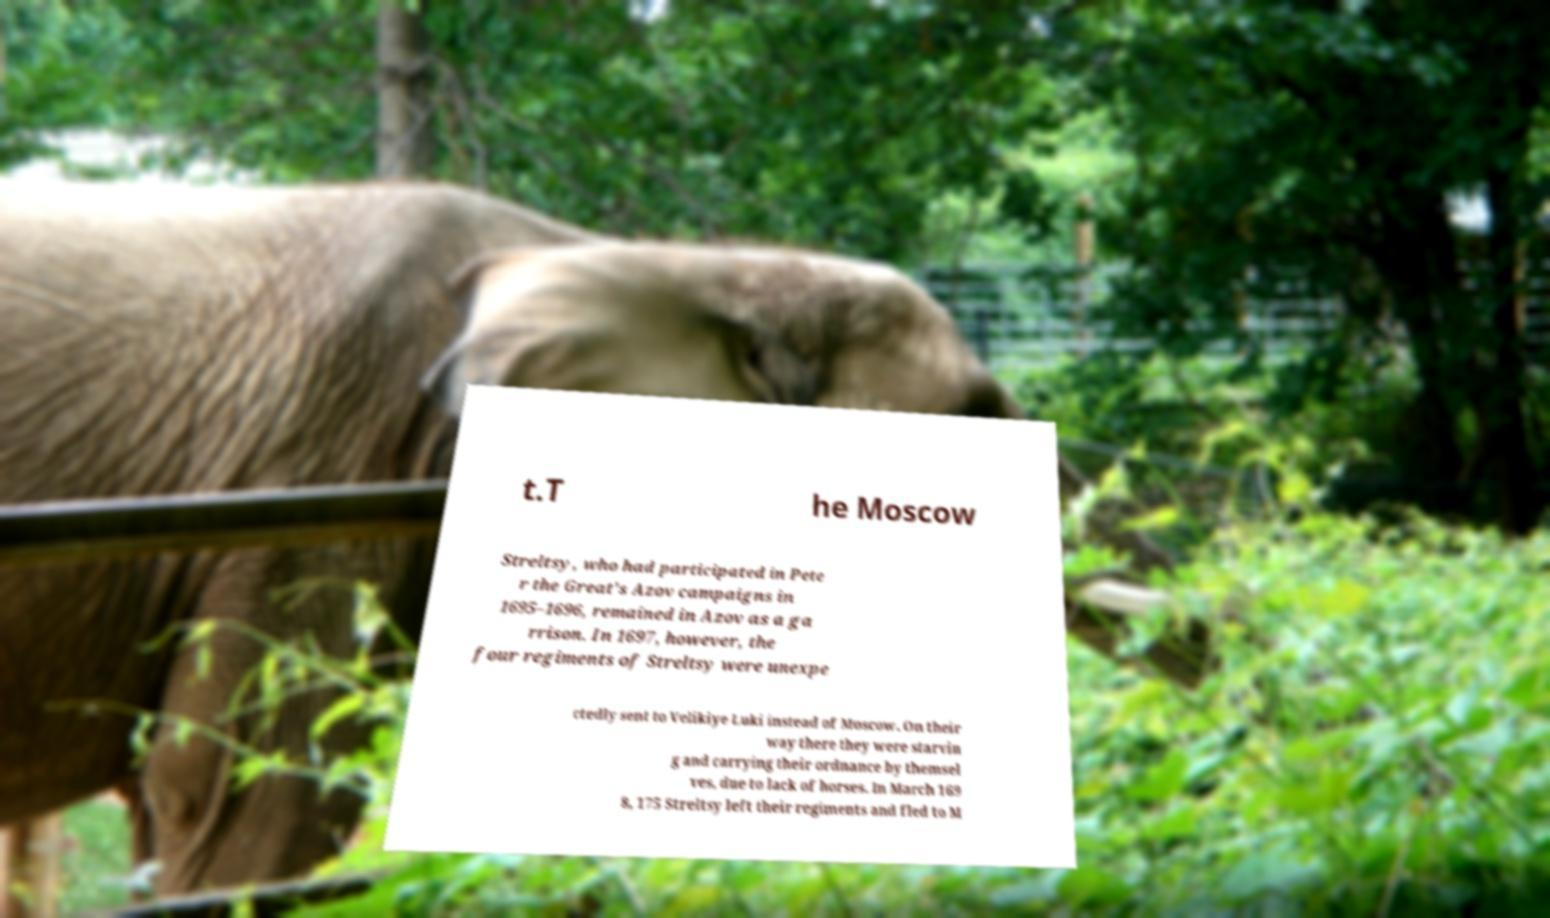Could you extract and type out the text from this image? t.T he Moscow Streltsy, who had participated in Pete r the Great's Azov campaigns in 1695–1696, remained in Azov as a ga rrison. In 1697, however, the four regiments of Streltsy were unexpe ctedly sent to Velikiye Luki instead of Moscow. On their way there they were starvin g and carrying their ordnance by themsel ves, due to lack of horses. In March 169 8, 175 Streltsy left their regiments and fled to M 